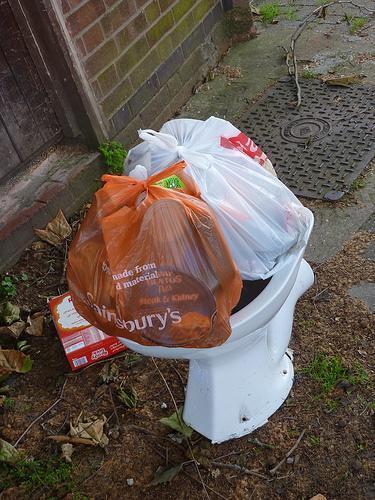How many shopping bags are in the toilet?
Give a very brief answer. 2. 